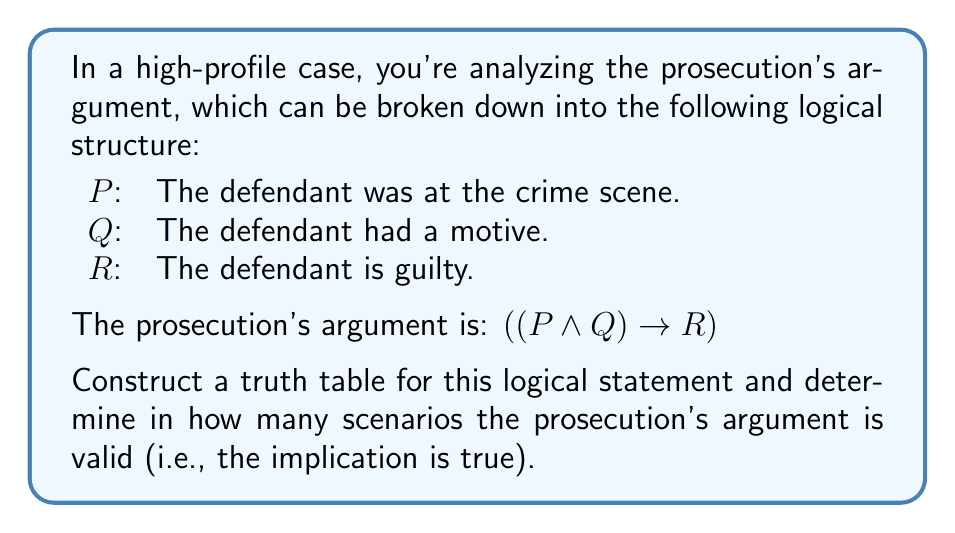Give your solution to this math problem. To analyze this logical structure, we need to create a truth table for the statement $((P \land Q) \rightarrow R)$. Let's break it down step-by-step:

1. First, we'll list all possible combinations of truth values for P, Q, and R:

   P | Q | R
   ---------------
   T | T | T
   T | T | F
   T | F | T
   T | F | F
   F | T | T
   F | T | F
   F | F | T
   F | F | F

2. Next, we'll evaluate $(P \land Q)$:

   P | Q | R | (P ∧ Q)
   ----------------------
   T | T | T |    T
   T | T | F |    T
   T | F | T |    F
   T | F | F |    F
   F | T | T |    F
   F | T | F |    F
   F | F | T |    F
   F | F | F |    F

3. Finally, we'll evaluate the implication $((P \land Q) \rightarrow R)$:

   P | Q | R | (P ∧ Q) | ((P ∧ Q) → R)
   -------------------------------------
   T | T | T |    T    |       T
   T | T | F |    T    |       F
   T | F | T |    F    |       T
   T | F | F |    F    |       T
   F | T | T |    F    |       T
   F | T | F |    F    |       T
   F | F | T |    F    |       T
   F | F | F |    F    |       T

Remember, an implication is false only when the antecedent is true and the consequent is false. In all other cases, it's true.

Counting the number of true values in the final column, we see that the prosecution's argument is valid (true) in 7 out of 8 scenarios.
Answer: The prosecution's argument is valid in 7 scenarios. 